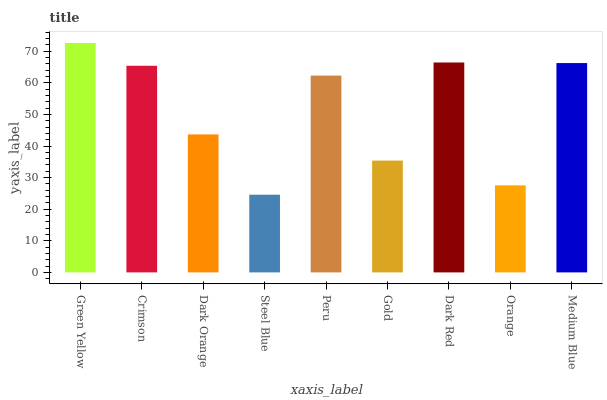Is Crimson the minimum?
Answer yes or no. No. Is Crimson the maximum?
Answer yes or no. No. Is Green Yellow greater than Crimson?
Answer yes or no. Yes. Is Crimson less than Green Yellow?
Answer yes or no. Yes. Is Crimson greater than Green Yellow?
Answer yes or no. No. Is Green Yellow less than Crimson?
Answer yes or no. No. Is Peru the high median?
Answer yes or no. Yes. Is Peru the low median?
Answer yes or no. Yes. Is Gold the high median?
Answer yes or no. No. Is Steel Blue the low median?
Answer yes or no. No. 